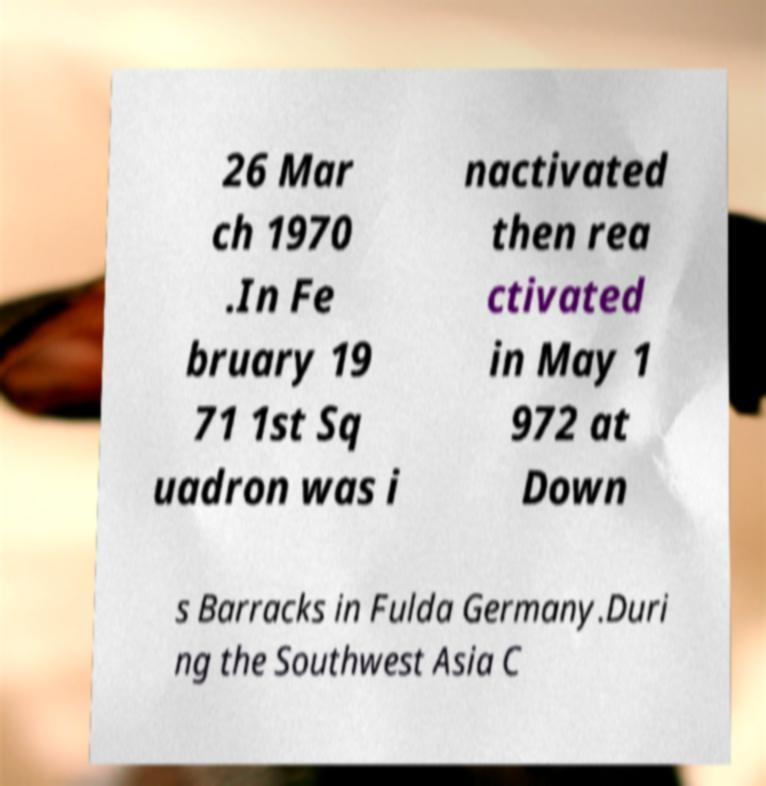Can you accurately transcribe the text from the provided image for me? 26 Mar ch 1970 .In Fe bruary 19 71 1st Sq uadron was i nactivated then rea ctivated in May 1 972 at Down s Barracks in Fulda Germany.Duri ng the Southwest Asia C 